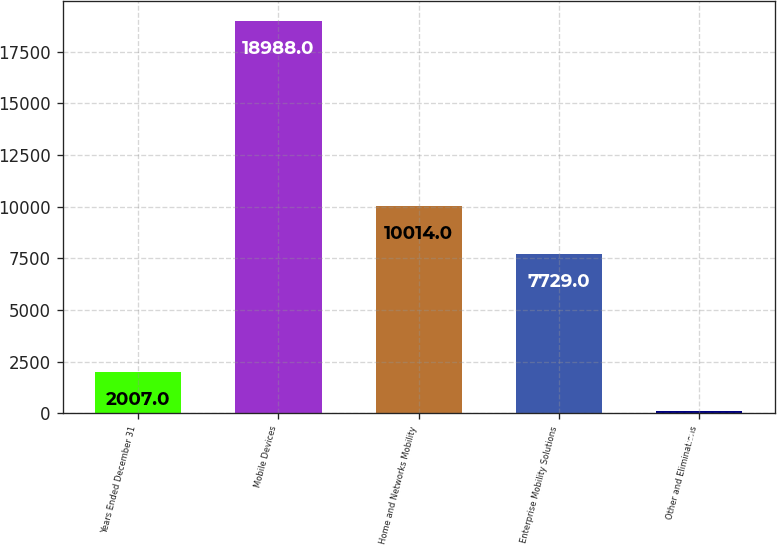<chart> <loc_0><loc_0><loc_500><loc_500><bar_chart><fcel>Years Ended December 31<fcel>Mobile Devices<fcel>Home and Networks Mobility<fcel>Enterprise Mobility Solutions<fcel>Other and Eliminations<nl><fcel>2007<fcel>18988<fcel>10014<fcel>7729<fcel>109<nl></chart> 